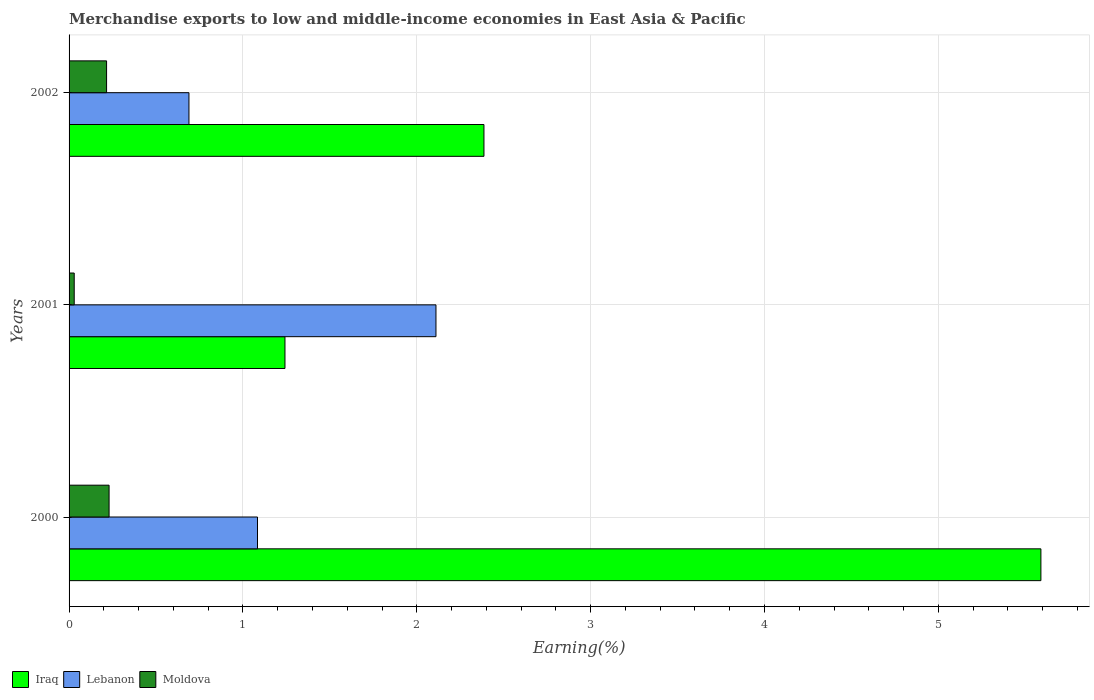How many groups of bars are there?
Provide a short and direct response. 3. Are the number of bars per tick equal to the number of legend labels?
Ensure brevity in your answer.  Yes. How many bars are there on the 2nd tick from the top?
Your answer should be very brief. 3. What is the label of the 1st group of bars from the top?
Keep it short and to the point. 2002. In how many cases, is the number of bars for a given year not equal to the number of legend labels?
Your answer should be compact. 0. What is the percentage of amount earned from merchandise exports in Iraq in 2001?
Your answer should be compact. 1.24. Across all years, what is the maximum percentage of amount earned from merchandise exports in Iraq?
Your response must be concise. 5.59. Across all years, what is the minimum percentage of amount earned from merchandise exports in Moldova?
Offer a very short reply. 0.03. In which year was the percentage of amount earned from merchandise exports in Iraq maximum?
Make the answer very short. 2000. What is the total percentage of amount earned from merchandise exports in Moldova in the graph?
Keep it short and to the point. 0.48. What is the difference between the percentage of amount earned from merchandise exports in Iraq in 2000 and that in 2002?
Provide a short and direct response. 3.2. What is the difference between the percentage of amount earned from merchandise exports in Iraq in 2001 and the percentage of amount earned from merchandise exports in Lebanon in 2002?
Your response must be concise. 0.55. What is the average percentage of amount earned from merchandise exports in Iraq per year?
Your answer should be very brief. 3.07. In the year 2002, what is the difference between the percentage of amount earned from merchandise exports in Lebanon and percentage of amount earned from merchandise exports in Moldova?
Make the answer very short. 0.47. In how many years, is the percentage of amount earned from merchandise exports in Lebanon greater than 1.4 %?
Keep it short and to the point. 1. What is the ratio of the percentage of amount earned from merchandise exports in Iraq in 2000 to that in 2001?
Provide a succinct answer. 4.5. Is the percentage of amount earned from merchandise exports in Lebanon in 2000 less than that in 2002?
Ensure brevity in your answer.  No. What is the difference between the highest and the second highest percentage of amount earned from merchandise exports in Lebanon?
Provide a short and direct response. 1.03. What is the difference between the highest and the lowest percentage of amount earned from merchandise exports in Lebanon?
Keep it short and to the point. 1.42. In how many years, is the percentage of amount earned from merchandise exports in Moldova greater than the average percentage of amount earned from merchandise exports in Moldova taken over all years?
Give a very brief answer. 2. Is the sum of the percentage of amount earned from merchandise exports in Lebanon in 2000 and 2001 greater than the maximum percentage of amount earned from merchandise exports in Iraq across all years?
Keep it short and to the point. No. What does the 3rd bar from the top in 2001 represents?
Offer a terse response. Iraq. What does the 3rd bar from the bottom in 2000 represents?
Your response must be concise. Moldova. Is it the case that in every year, the sum of the percentage of amount earned from merchandise exports in Moldova and percentage of amount earned from merchandise exports in Lebanon is greater than the percentage of amount earned from merchandise exports in Iraq?
Make the answer very short. No. Are all the bars in the graph horizontal?
Provide a succinct answer. Yes. How many years are there in the graph?
Provide a short and direct response. 3. Where does the legend appear in the graph?
Provide a short and direct response. Bottom left. How many legend labels are there?
Make the answer very short. 3. How are the legend labels stacked?
Offer a terse response. Horizontal. What is the title of the graph?
Offer a very short reply. Merchandise exports to low and middle-income economies in East Asia & Pacific. Does "Turkey" appear as one of the legend labels in the graph?
Provide a succinct answer. No. What is the label or title of the X-axis?
Offer a terse response. Earning(%). What is the Earning(%) of Iraq in 2000?
Your answer should be compact. 5.59. What is the Earning(%) of Lebanon in 2000?
Your answer should be compact. 1.08. What is the Earning(%) in Moldova in 2000?
Provide a short and direct response. 0.23. What is the Earning(%) of Iraq in 2001?
Provide a short and direct response. 1.24. What is the Earning(%) in Lebanon in 2001?
Your response must be concise. 2.11. What is the Earning(%) in Moldova in 2001?
Make the answer very short. 0.03. What is the Earning(%) of Iraq in 2002?
Your answer should be compact. 2.39. What is the Earning(%) in Lebanon in 2002?
Offer a terse response. 0.69. What is the Earning(%) of Moldova in 2002?
Give a very brief answer. 0.22. Across all years, what is the maximum Earning(%) of Iraq?
Keep it short and to the point. 5.59. Across all years, what is the maximum Earning(%) of Lebanon?
Your answer should be compact. 2.11. Across all years, what is the maximum Earning(%) of Moldova?
Make the answer very short. 0.23. Across all years, what is the minimum Earning(%) of Iraq?
Keep it short and to the point. 1.24. Across all years, what is the minimum Earning(%) in Lebanon?
Keep it short and to the point. 0.69. Across all years, what is the minimum Earning(%) of Moldova?
Keep it short and to the point. 0.03. What is the total Earning(%) of Iraq in the graph?
Provide a short and direct response. 9.22. What is the total Earning(%) of Lebanon in the graph?
Provide a short and direct response. 3.88. What is the total Earning(%) in Moldova in the graph?
Provide a succinct answer. 0.48. What is the difference between the Earning(%) of Iraq in 2000 and that in 2001?
Ensure brevity in your answer.  4.35. What is the difference between the Earning(%) in Lebanon in 2000 and that in 2001?
Keep it short and to the point. -1.03. What is the difference between the Earning(%) of Moldova in 2000 and that in 2001?
Your answer should be very brief. 0.2. What is the difference between the Earning(%) in Iraq in 2000 and that in 2002?
Give a very brief answer. 3.2. What is the difference between the Earning(%) in Lebanon in 2000 and that in 2002?
Offer a terse response. 0.39. What is the difference between the Earning(%) in Moldova in 2000 and that in 2002?
Your answer should be very brief. 0.01. What is the difference between the Earning(%) in Iraq in 2001 and that in 2002?
Offer a terse response. -1.14. What is the difference between the Earning(%) in Lebanon in 2001 and that in 2002?
Your answer should be very brief. 1.42. What is the difference between the Earning(%) in Moldova in 2001 and that in 2002?
Ensure brevity in your answer.  -0.19. What is the difference between the Earning(%) of Iraq in 2000 and the Earning(%) of Lebanon in 2001?
Provide a succinct answer. 3.48. What is the difference between the Earning(%) in Iraq in 2000 and the Earning(%) in Moldova in 2001?
Your answer should be compact. 5.56. What is the difference between the Earning(%) of Lebanon in 2000 and the Earning(%) of Moldova in 2001?
Offer a terse response. 1.05. What is the difference between the Earning(%) of Iraq in 2000 and the Earning(%) of Lebanon in 2002?
Your answer should be very brief. 4.9. What is the difference between the Earning(%) of Iraq in 2000 and the Earning(%) of Moldova in 2002?
Provide a short and direct response. 5.37. What is the difference between the Earning(%) of Lebanon in 2000 and the Earning(%) of Moldova in 2002?
Your answer should be very brief. 0.87. What is the difference between the Earning(%) in Iraq in 2001 and the Earning(%) in Lebanon in 2002?
Offer a terse response. 0.55. What is the difference between the Earning(%) of Iraq in 2001 and the Earning(%) of Moldova in 2002?
Your response must be concise. 1.03. What is the difference between the Earning(%) of Lebanon in 2001 and the Earning(%) of Moldova in 2002?
Provide a succinct answer. 1.89. What is the average Earning(%) of Iraq per year?
Your answer should be compact. 3.07. What is the average Earning(%) of Lebanon per year?
Keep it short and to the point. 1.29. What is the average Earning(%) in Moldova per year?
Your answer should be very brief. 0.16. In the year 2000, what is the difference between the Earning(%) of Iraq and Earning(%) of Lebanon?
Keep it short and to the point. 4.51. In the year 2000, what is the difference between the Earning(%) in Iraq and Earning(%) in Moldova?
Give a very brief answer. 5.36. In the year 2000, what is the difference between the Earning(%) in Lebanon and Earning(%) in Moldova?
Your response must be concise. 0.85. In the year 2001, what is the difference between the Earning(%) of Iraq and Earning(%) of Lebanon?
Keep it short and to the point. -0.87. In the year 2001, what is the difference between the Earning(%) of Iraq and Earning(%) of Moldova?
Keep it short and to the point. 1.21. In the year 2001, what is the difference between the Earning(%) of Lebanon and Earning(%) of Moldova?
Your response must be concise. 2.08. In the year 2002, what is the difference between the Earning(%) in Iraq and Earning(%) in Lebanon?
Your answer should be compact. 1.7. In the year 2002, what is the difference between the Earning(%) in Iraq and Earning(%) in Moldova?
Ensure brevity in your answer.  2.17. In the year 2002, what is the difference between the Earning(%) of Lebanon and Earning(%) of Moldova?
Give a very brief answer. 0.47. What is the ratio of the Earning(%) in Iraq in 2000 to that in 2001?
Provide a short and direct response. 4.5. What is the ratio of the Earning(%) in Lebanon in 2000 to that in 2001?
Give a very brief answer. 0.51. What is the ratio of the Earning(%) of Moldova in 2000 to that in 2001?
Make the answer very short. 7.78. What is the ratio of the Earning(%) of Iraq in 2000 to that in 2002?
Provide a short and direct response. 2.34. What is the ratio of the Earning(%) in Lebanon in 2000 to that in 2002?
Make the answer very short. 1.57. What is the ratio of the Earning(%) of Moldova in 2000 to that in 2002?
Offer a very short reply. 1.07. What is the ratio of the Earning(%) of Iraq in 2001 to that in 2002?
Keep it short and to the point. 0.52. What is the ratio of the Earning(%) of Lebanon in 2001 to that in 2002?
Make the answer very short. 3.06. What is the ratio of the Earning(%) of Moldova in 2001 to that in 2002?
Give a very brief answer. 0.14. What is the difference between the highest and the second highest Earning(%) in Iraq?
Your response must be concise. 3.2. What is the difference between the highest and the second highest Earning(%) of Lebanon?
Your answer should be compact. 1.03. What is the difference between the highest and the second highest Earning(%) of Moldova?
Provide a succinct answer. 0.01. What is the difference between the highest and the lowest Earning(%) of Iraq?
Give a very brief answer. 4.35. What is the difference between the highest and the lowest Earning(%) in Lebanon?
Give a very brief answer. 1.42. What is the difference between the highest and the lowest Earning(%) in Moldova?
Keep it short and to the point. 0.2. 